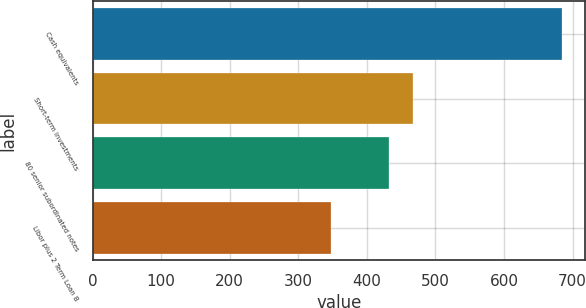<chart> <loc_0><loc_0><loc_500><loc_500><bar_chart><fcel>Cash equivalents<fcel>Short-term investments<fcel>80 senior subordinated notes<fcel>Libor plus 2 Term Loan B<nl><fcel>684<fcel>466.6<fcel>433<fcel>348<nl></chart> 